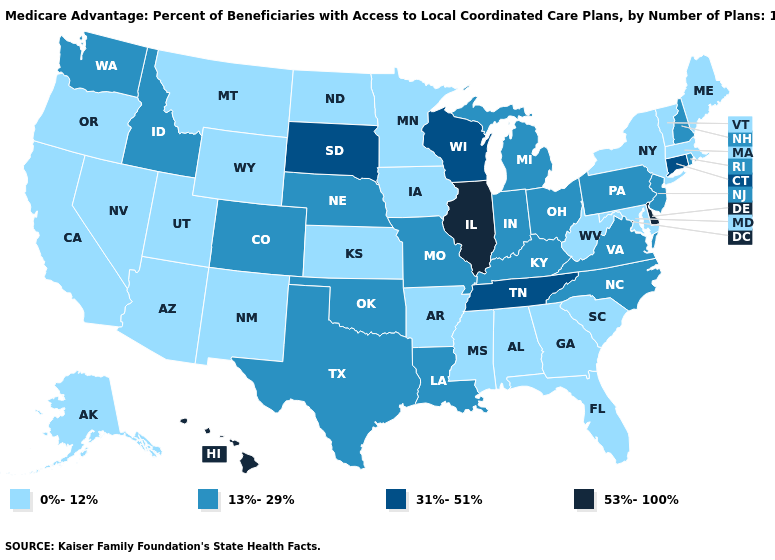Name the states that have a value in the range 13%-29%?
Quick response, please. Colorado, Idaho, Indiana, Kentucky, Louisiana, Michigan, Missouri, North Carolina, Nebraska, New Hampshire, New Jersey, Ohio, Oklahoma, Pennsylvania, Rhode Island, Texas, Virginia, Washington. What is the value of North Dakota?
Give a very brief answer. 0%-12%. What is the value of Virginia?
Short answer required. 13%-29%. What is the lowest value in states that border New Mexico?
Keep it brief. 0%-12%. What is the lowest value in states that border Tennessee?
Answer briefly. 0%-12%. Among the states that border Arkansas , which have the lowest value?
Quick response, please. Mississippi. Name the states that have a value in the range 13%-29%?
Answer briefly. Colorado, Idaho, Indiana, Kentucky, Louisiana, Michigan, Missouri, North Carolina, Nebraska, New Hampshire, New Jersey, Ohio, Oklahoma, Pennsylvania, Rhode Island, Texas, Virginia, Washington. What is the value of Wisconsin?
Answer briefly. 31%-51%. Name the states that have a value in the range 13%-29%?
Be succinct. Colorado, Idaho, Indiana, Kentucky, Louisiana, Michigan, Missouri, North Carolina, Nebraska, New Hampshire, New Jersey, Ohio, Oklahoma, Pennsylvania, Rhode Island, Texas, Virginia, Washington. What is the value of Illinois?
Write a very short answer. 53%-100%. What is the highest value in states that border Indiana?
Answer briefly. 53%-100%. Does Maine have the highest value in the Northeast?
Quick response, please. No. How many symbols are there in the legend?
Concise answer only. 4. Does Oregon have the lowest value in the West?
Concise answer only. Yes. 